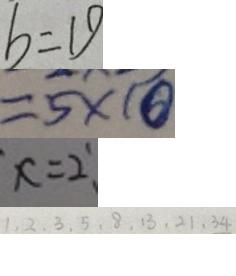<formula> <loc_0><loc_0><loc_500><loc_500>b = 1 9 
 = 5 \times 1 0 
 x = 2 
 1 , 2 , 3 , 5 , 8 , 1 3 , 2 1 , 3 4</formula> 